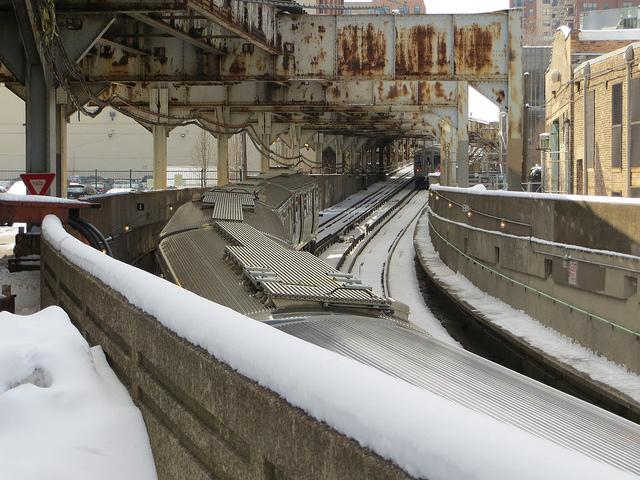What is located above the ironwork on top of the train that is heading away?

Choices:
A) coffee shop
B) factory
C) storefront
D) train track train track 